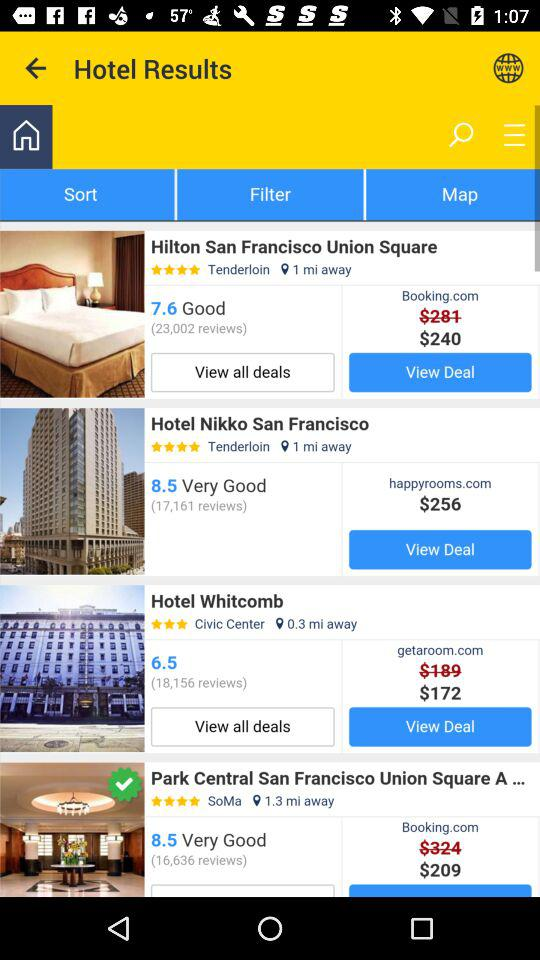How many of the hotels are in the Tenderloin area?
Answer the question using a single word or phrase. 2 